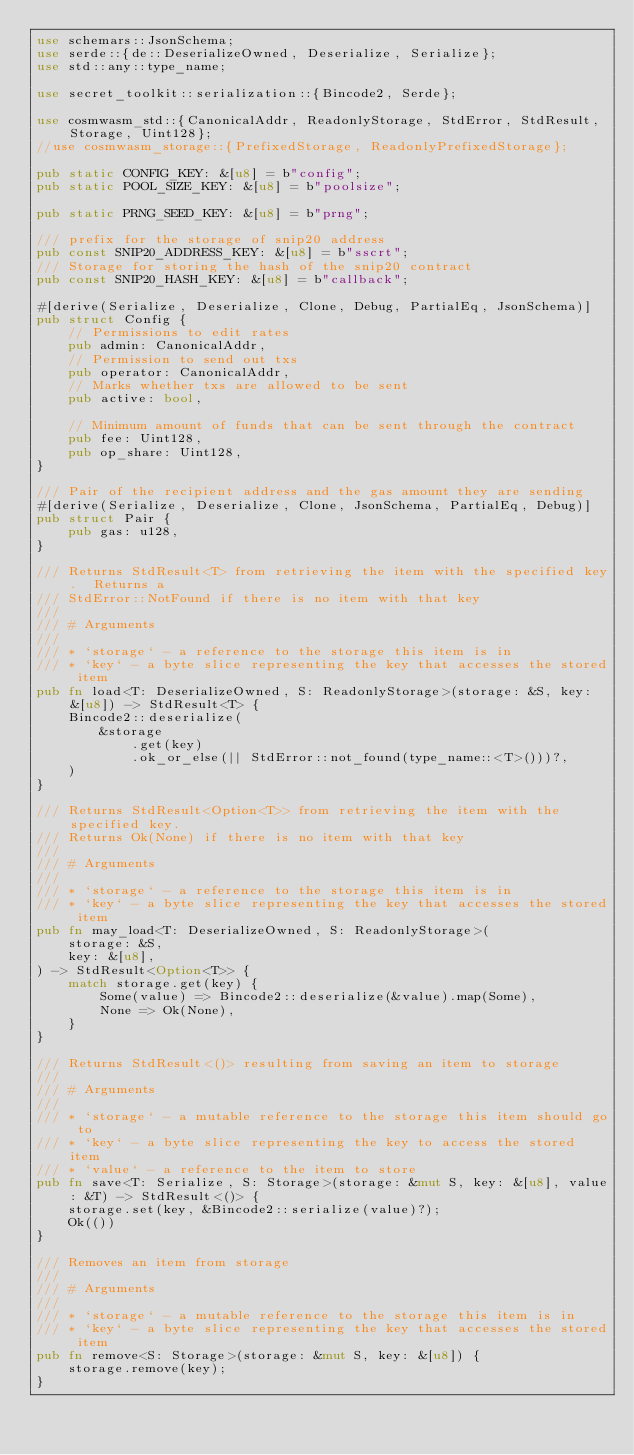Convert code to text. <code><loc_0><loc_0><loc_500><loc_500><_Rust_>use schemars::JsonSchema;
use serde::{de::DeserializeOwned, Deserialize, Serialize};
use std::any::type_name;

use secret_toolkit::serialization::{Bincode2, Serde};

use cosmwasm_std::{CanonicalAddr, ReadonlyStorage, StdError, StdResult, Storage, Uint128};
//use cosmwasm_storage::{PrefixedStorage, ReadonlyPrefixedStorage};

pub static CONFIG_KEY: &[u8] = b"config";
pub static POOL_SIZE_KEY: &[u8] = b"poolsize";

pub static PRNG_SEED_KEY: &[u8] = b"prng";

/// prefix for the storage of snip20 address
pub const SNIP20_ADDRESS_KEY: &[u8] = b"sscrt";
/// Storage for storing the hash of the snip20 contract
pub const SNIP20_HASH_KEY: &[u8] = b"callback";

#[derive(Serialize, Deserialize, Clone, Debug, PartialEq, JsonSchema)]
pub struct Config {
    // Permissions to edit rates
    pub admin: CanonicalAddr,
    // Permission to send out txs
    pub operator: CanonicalAddr,
    // Marks whether txs are allowed to be sent
    pub active: bool,

    // Minimum amount of funds that can be sent through the contract
    pub fee: Uint128,
    pub op_share: Uint128,
}

/// Pair of the recipient address and the gas amount they are sending
#[derive(Serialize, Deserialize, Clone, JsonSchema, PartialEq, Debug)]
pub struct Pair {
    pub gas: u128,
}

/// Returns StdResult<T> from retrieving the item with the specified key.  Returns a
/// StdError::NotFound if there is no item with that key
///
/// # Arguments
///
/// * `storage` - a reference to the storage this item is in
/// * `key` - a byte slice representing the key that accesses the stored item
pub fn load<T: DeserializeOwned, S: ReadonlyStorage>(storage: &S, key: &[u8]) -> StdResult<T> {
    Bincode2::deserialize(
        &storage
            .get(key)
            .ok_or_else(|| StdError::not_found(type_name::<T>()))?,
    )
}

/// Returns StdResult<Option<T>> from retrieving the item with the specified key.
/// Returns Ok(None) if there is no item with that key
///
/// # Arguments
///
/// * `storage` - a reference to the storage this item is in
/// * `key` - a byte slice representing the key that accesses the stored item
pub fn may_load<T: DeserializeOwned, S: ReadonlyStorage>(
    storage: &S,
    key: &[u8],
) -> StdResult<Option<T>> {
    match storage.get(key) {
        Some(value) => Bincode2::deserialize(&value).map(Some),
        None => Ok(None),
    }
}

/// Returns StdResult<()> resulting from saving an item to storage
///
/// # Arguments
///
/// * `storage` - a mutable reference to the storage this item should go to
/// * `key` - a byte slice representing the key to access the stored item
/// * `value` - a reference to the item to store
pub fn save<T: Serialize, S: Storage>(storage: &mut S, key: &[u8], value: &T) -> StdResult<()> {
    storage.set(key, &Bincode2::serialize(value)?);
    Ok(())
}

/// Removes an item from storage
///
/// # Arguments
///
/// * `storage` - a mutable reference to the storage this item is in
/// * `key` - a byte slice representing the key that accesses the stored item
pub fn remove<S: Storage>(storage: &mut S, key: &[u8]) {
    storage.remove(key);
}
</code> 